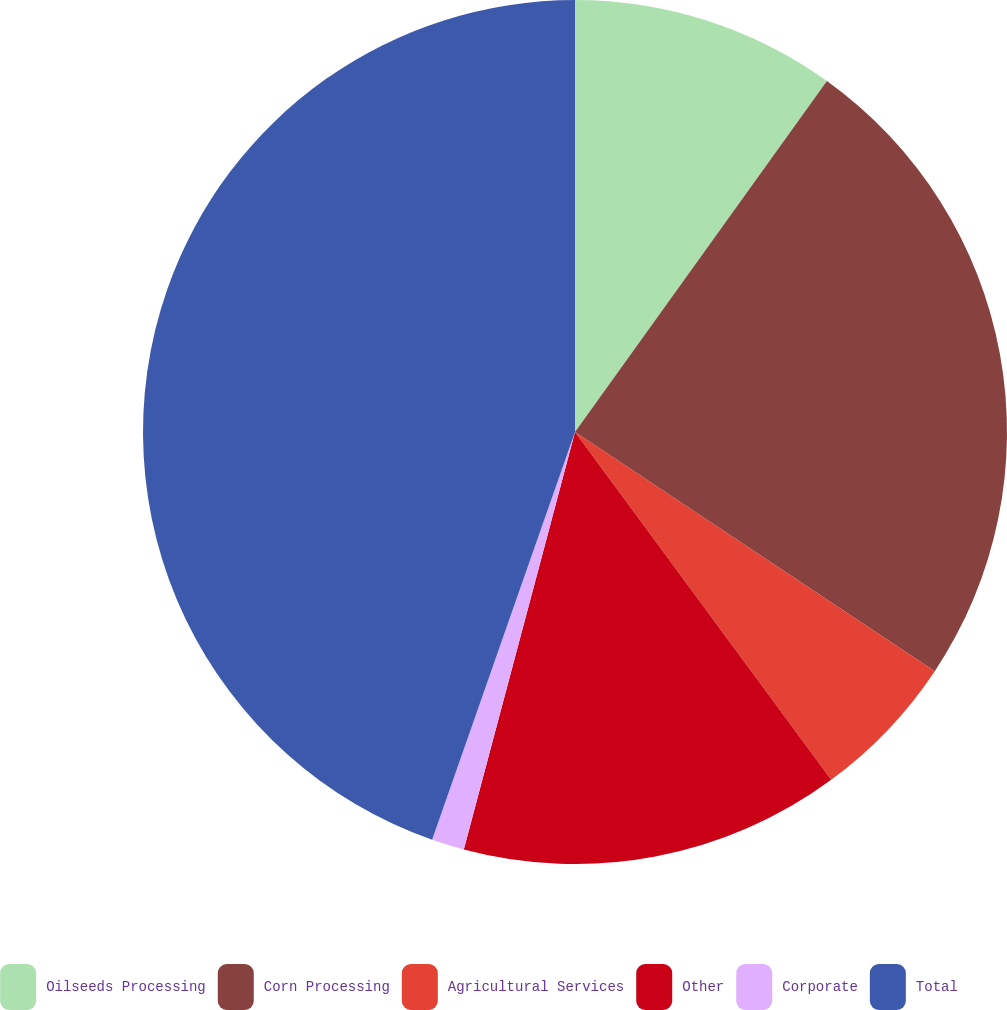Convert chart to OTSL. <chart><loc_0><loc_0><loc_500><loc_500><pie_chart><fcel>Oilseeds Processing<fcel>Corn Processing<fcel>Agricultural Services<fcel>Other<fcel>Corporate<fcel>Total<nl><fcel>9.91%<fcel>24.43%<fcel>5.56%<fcel>14.25%<fcel>1.22%<fcel>44.64%<nl></chart> 